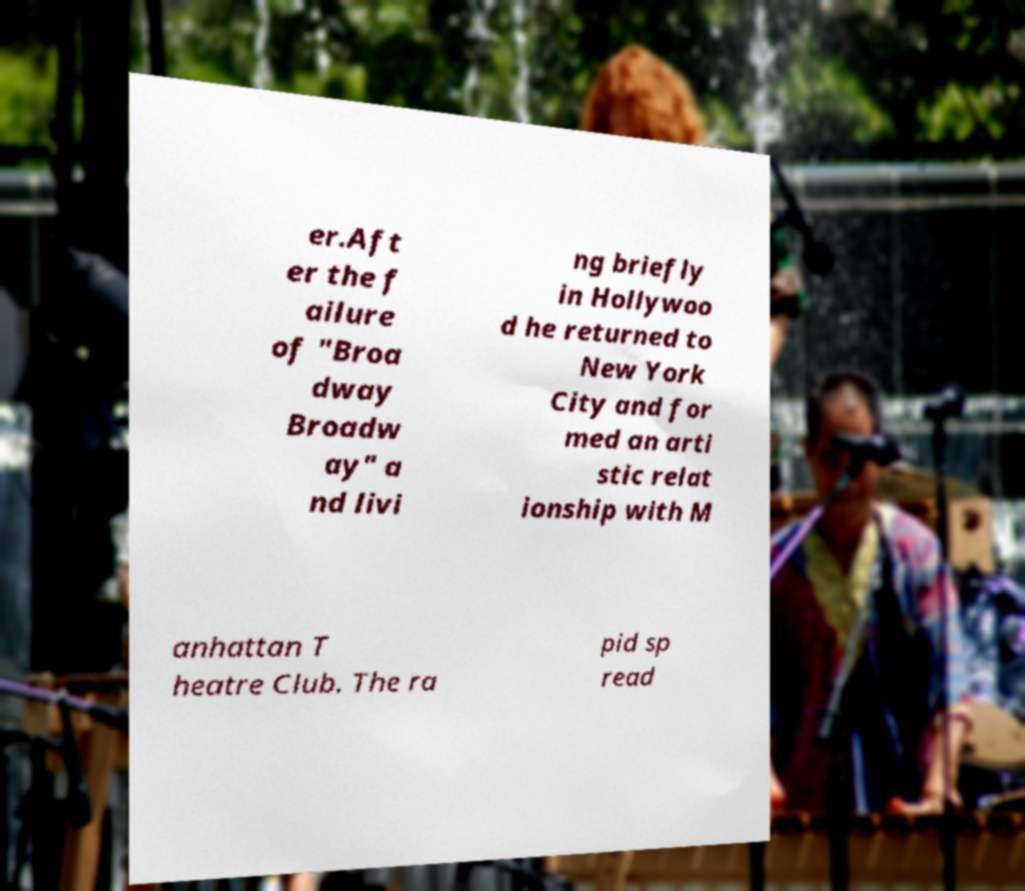Could you assist in decoding the text presented in this image and type it out clearly? er.Aft er the f ailure of "Broa dway Broadw ay" a nd livi ng briefly in Hollywoo d he returned to New York City and for med an arti stic relat ionship with M anhattan T heatre Club. The ra pid sp read 